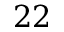<formula> <loc_0><loc_0><loc_500><loc_500>2 2</formula> 